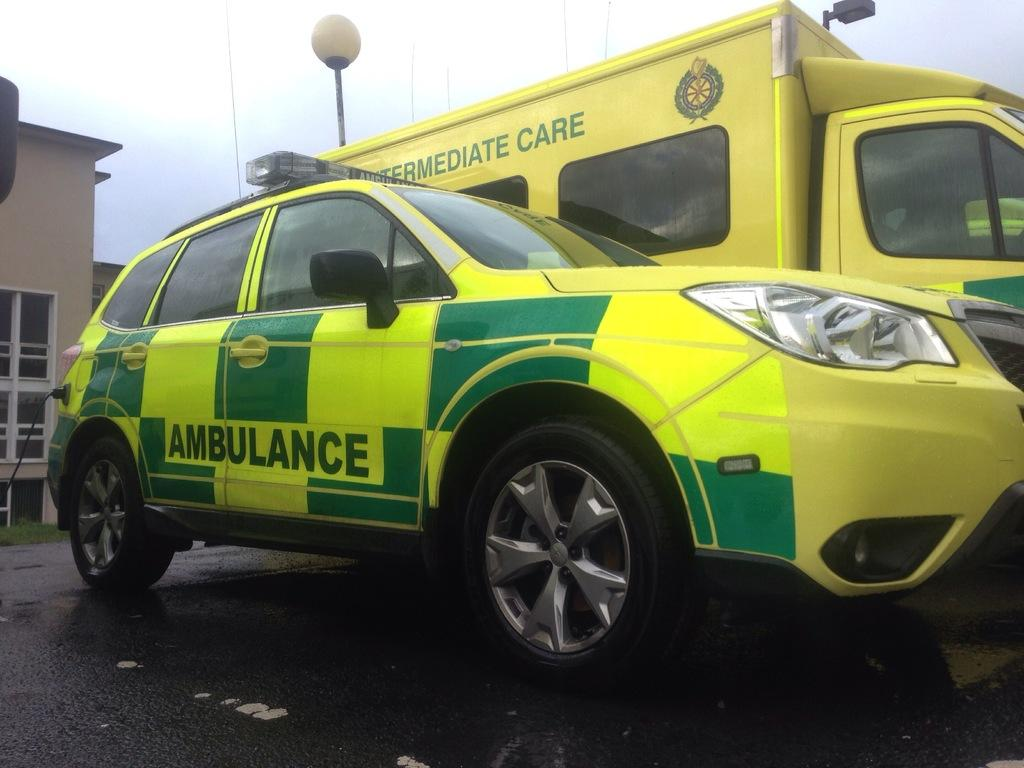<image>
Share a concise interpretation of the image provided. Two emergency vehicles, both ambulences they are yellow and green. 